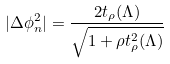Convert formula to latex. <formula><loc_0><loc_0><loc_500><loc_500>| \Delta \phi _ { n } ^ { 2 } | = \frac { 2 t _ { \rho } ( \Lambda ) } { \sqrt { 1 + \rho t _ { \rho } ^ { 2 } ( \Lambda ) } }</formula> 